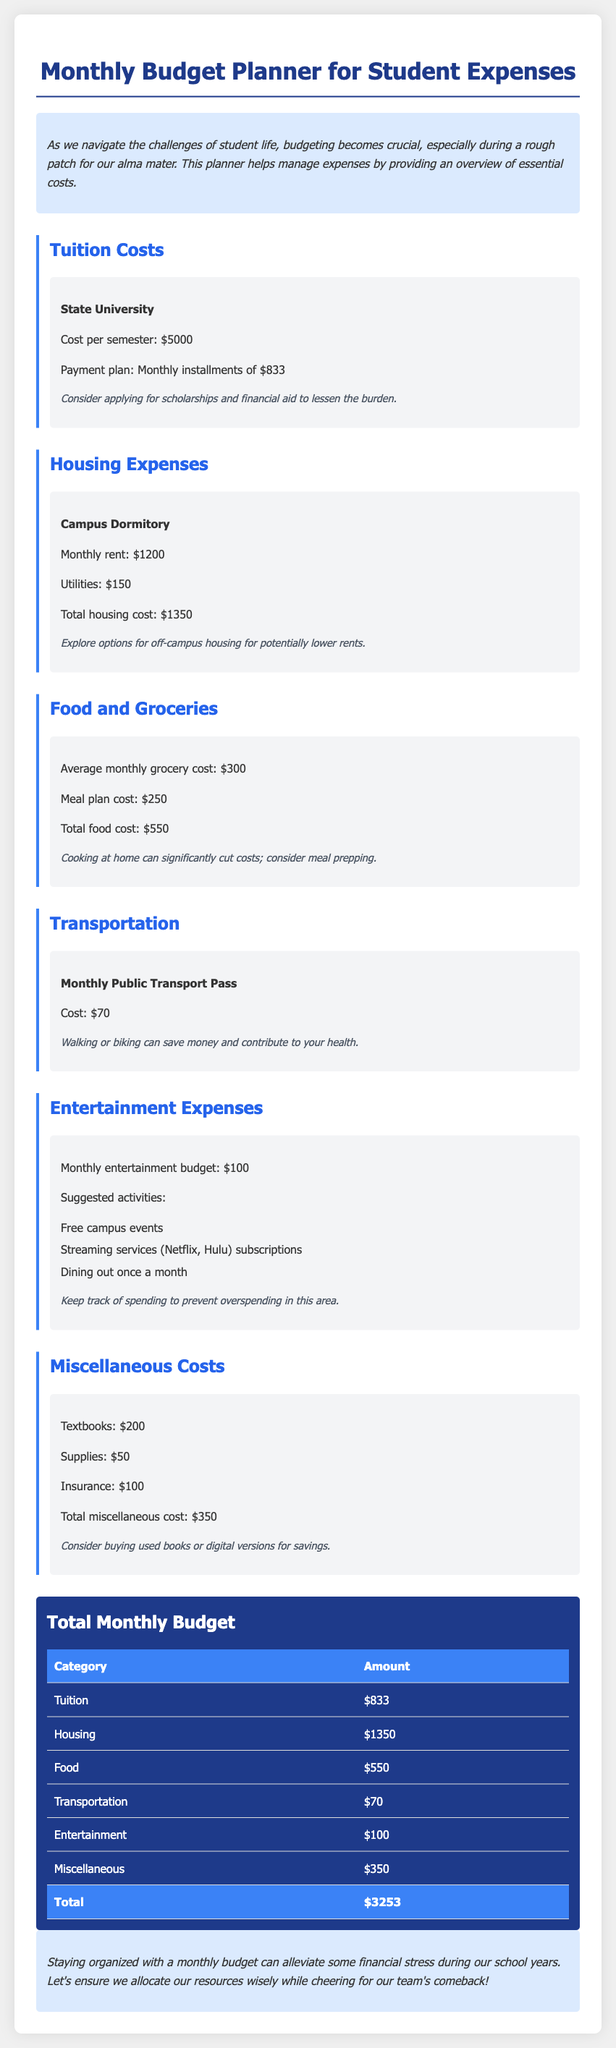What is the cost per semester for tuition? The document states the cost per semester for tuition is $5000.
Answer: $5000 What is the total housing cost? The total housing cost is calculated from the monthly rent and utilities, resulting in $1200 + $150 = $1350.
Answer: $1350 How much is the average monthly grocery cost? The document specifies that the average monthly grocery cost is $300.
Answer: $300 What is the cost of a monthly public transport pass? The document provides the cost of a monthly public transport pass as $70.
Answer: $70 What is the total monthly budget? The total monthly budget is the sum of all expenses listed, which totals $3253.
Answer: $3253 How much is allocated for entertainment expenses? The document mentions a monthly entertainment budget of $100.
Answer: $100 What is the total cost for miscellaneous expenses? The total cost for miscellaneous expenses is computed from textbooks, supplies, and insurance, amounting to $350.
Answer: $350 What are suggested activities for entertainment? The document lists free campus events, streaming services subscriptions, and dining out once a month as suggested activities.
Answer: Free campus events, streaming services, dining out What payment plan is available for tuition? The payment plan mentioned for tuition is monthly installments of $833.
Answer: Monthly installments of $833 